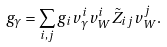<formula> <loc_0><loc_0><loc_500><loc_500>g _ { \gamma } = \sum _ { i , j } g _ { i } v ^ { i } _ { \gamma } v ^ { i } _ { W } \tilde { Z } _ { i j } v _ { W } ^ { j } .</formula> 